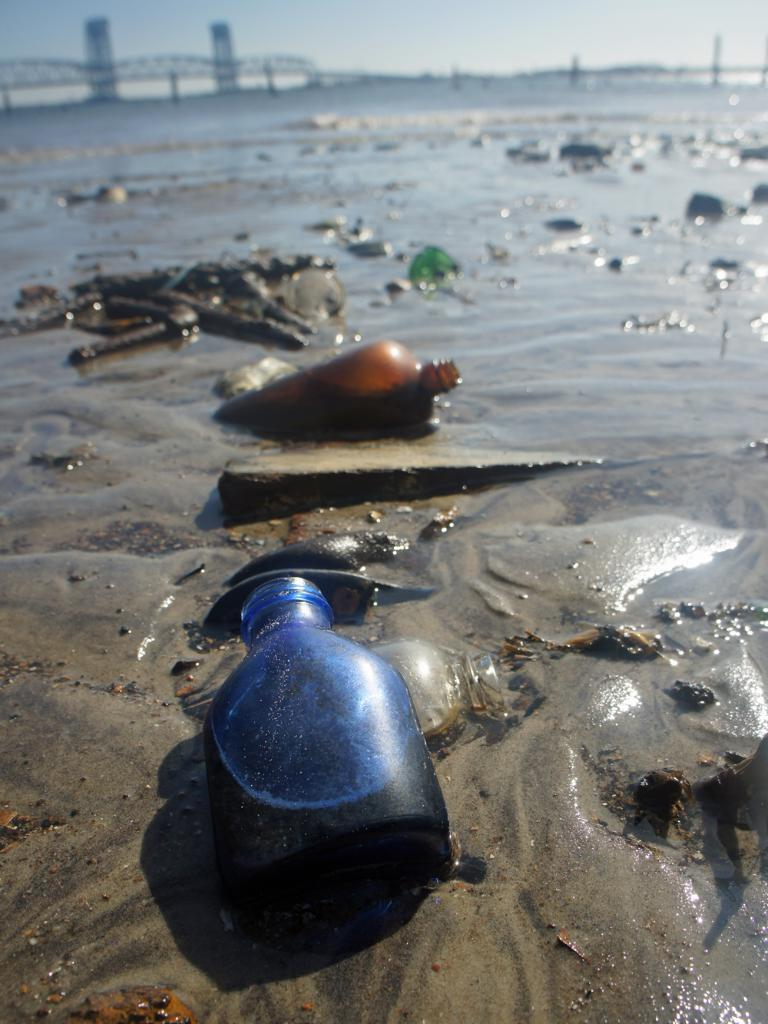What type of terrain is depicted in the image? There is sand with water in the image, which suggests a beach or shoreline. What objects can be seen in the image besides the terrain? There are different bottles visible in the image. What else is present in the image besides the terrain and bottles? There is dirt or mud in the image. What can be seen in the distance in the image? A bridge is present in the distance. What is visible above the terrain in the image? The sky is visible in the image. What type of rose is growing near the bottles in the image? There are no roses present in the image; it features sand, water, bottles, dirt or mud, a bridge, and the sky. 